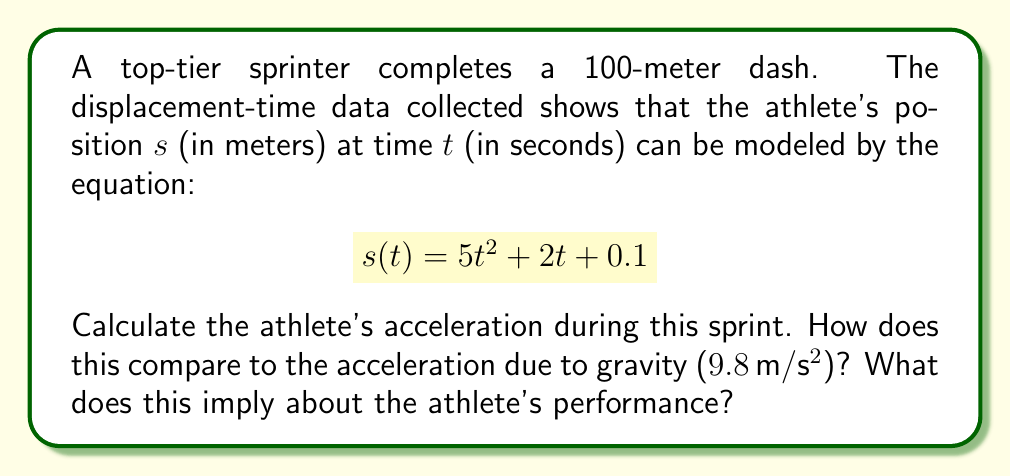Can you answer this question? To find the acceleration of the athlete, we need to analyze the given displacement-time equation:

$$s(t) = 5t^2 + 2t + 0.1$$

1. First, we recall that acceleration is the second derivative of displacement with respect to time.

2. Let's find the first derivative, which represents velocity:
   $$v(t) = \frac{ds}{dt} = 10t + 2$$

3. Now, let's find the second derivative, which represents acceleration:
   $$a(t) = \frac{dv}{dt} = 10$$

4. The acceleration is constant at $10 \, \text{m}/\text{s}^2$.

5. Comparing this to the acceleration due to gravity ($9.8 \, \text{m}/\text{s}^2$):
   $$\frac{10 \, \text{m}/\text{s}^2}{9.8 \, \text{m}/\text{s}^2} \approx 1.02$$

This means the athlete's acceleration is about 2% greater than the acceleration due to gravity.

Implications for the athlete's performance:

1. The constant acceleration of $10 \, \text{m}/\text{s}^2$ indicates a very powerful and consistent sprint.
2. Accelerating faster than gravity is an exceptional feat, showcasing the athlete's elite level of performance.
3. This level of acceleration suggests the athlete is likely operating at or near their peak potential.
Answer: The athlete's acceleration during the sprint is $10 \, \text{m}/\text{s}^2$, which is approximately 1.02 times the acceleration due to gravity. This implies an exceptional level of performance, with the athlete likely operating at or near their peak potential. 